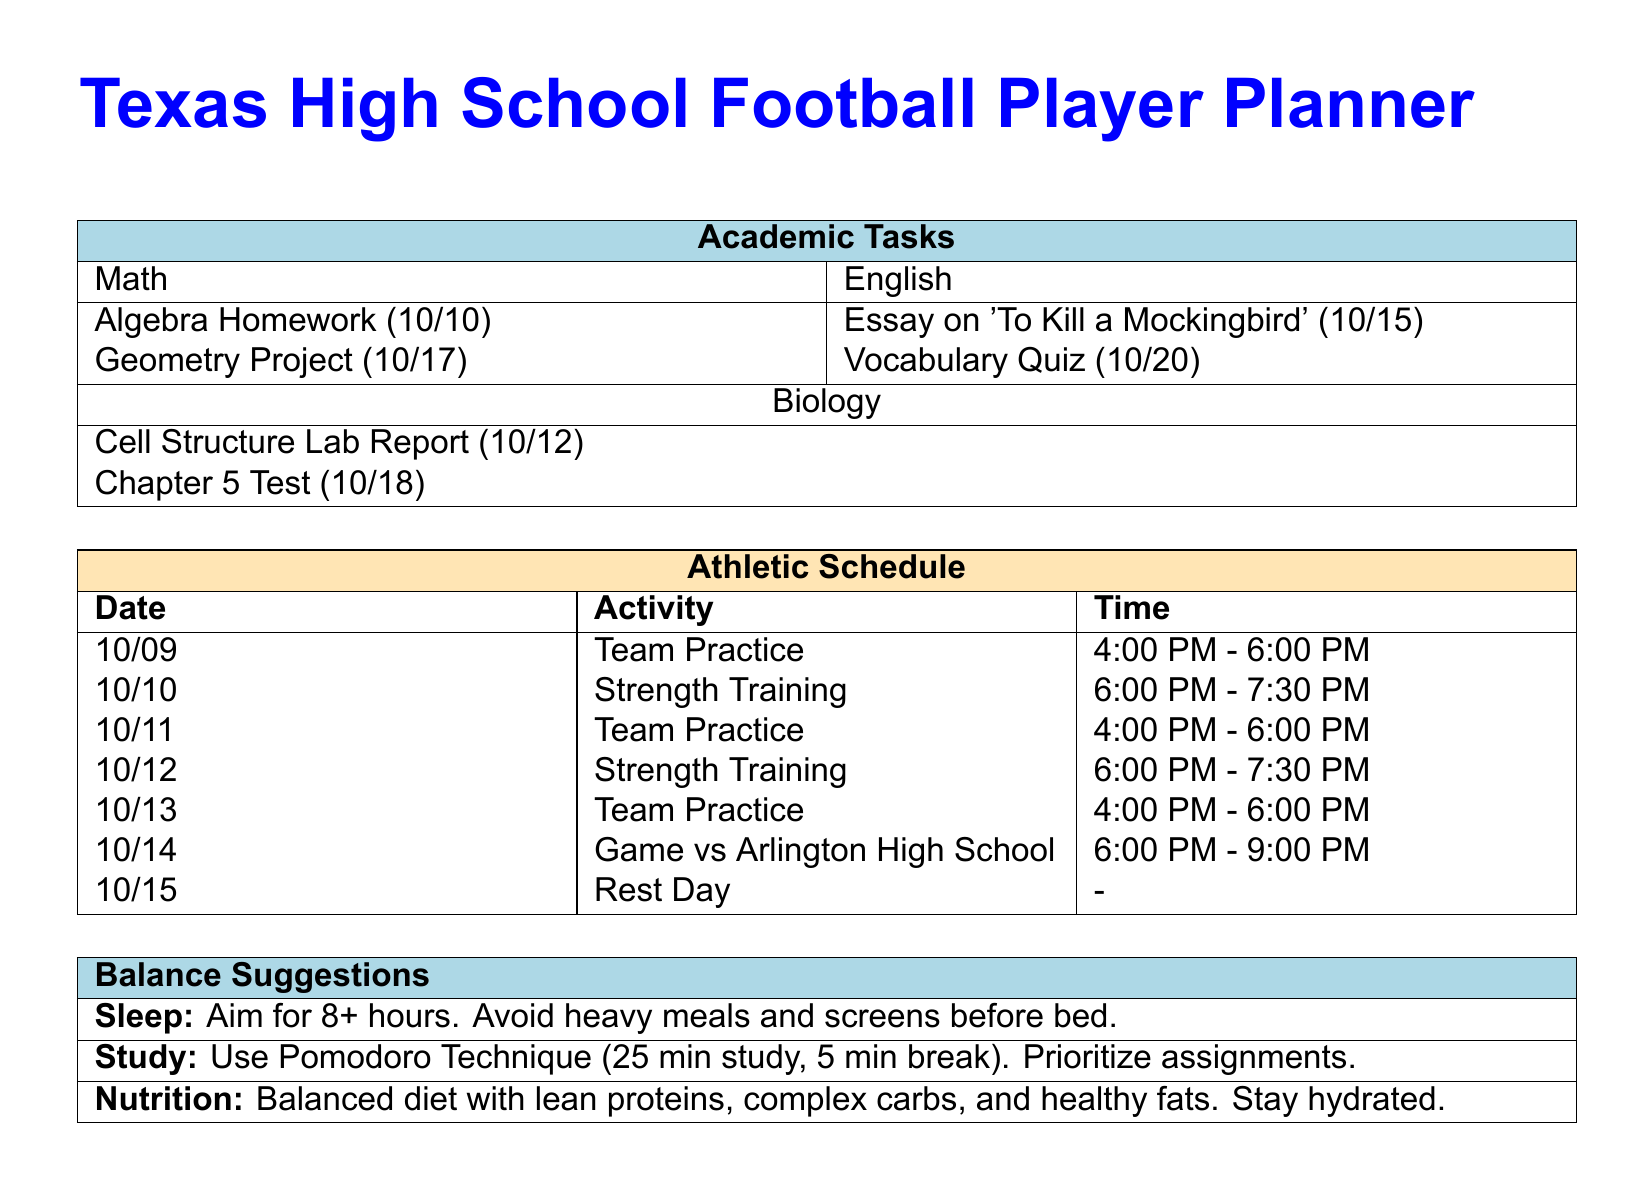What is the deadline for the Algebra homework? The deadline for the Algebra homework is specified in the Academic Tasks section of the document as 10/10.
Answer: 10/10 When is the Vocabulary Quiz scheduled? The Vocabulary Quiz is listed under English in the Academic Tasks and has a deadline of 10/20.
Answer: 10/20 What activity is scheduled for 10/14? The Athletic Schedule states that a game is scheduled against Arlington High School on 10/14.
Answer: Game vs Arlington High School How many sleep hours are suggested? The Balance Suggestions section recommends aiming for 8 or more hours of sleep.
Answer: 8+ What technique is suggested for studying? The Balance Suggestions recommend using the Pomodoro Technique for effective studying.
Answer: Pomodoro Technique On which date is a Rest Day scheduled? The document specifies that a Rest Day is scheduled for 10/15 in the Athletic Schedule.
Answer: 10/15 How long is the Strength Training session on 10/10? The duration for Strength Training on 10/10 is indicated as 1.5 hours, from 6:00 PM to 7:30 PM.
Answer: 1.5 hours What type of project is due on 10/17? The project due on 10/17 is a Geometry Project noted in the Academic Tasks section.
Answer: Geometry Project How is hydration addressed in the Balance Suggestions? The document suggests staying hydrated as part of the nutrition guidance in the Balance Suggestions.
Answer: Stay hydrated 